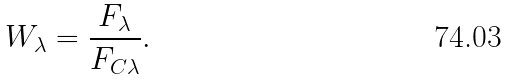<formula> <loc_0><loc_0><loc_500><loc_500>W _ { \lambda } = \frac { F _ { \lambda } } { F _ { C \lambda } } .</formula> 